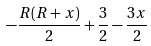<formula> <loc_0><loc_0><loc_500><loc_500>- \frac { R ( R + x ) } { 2 } + \frac { 3 } { 2 } - \frac { 3 x } { 2 }</formula> 